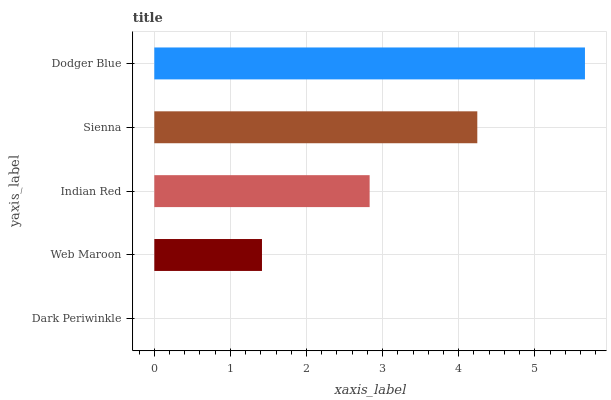Is Dark Periwinkle the minimum?
Answer yes or no. Yes. Is Dodger Blue the maximum?
Answer yes or no. Yes. Is Web Maroon the minimum?
Answer yes or no. No. Is Web Maroon the maximum?
Answer yes or no. No. Is Web Maroon greater than Dark Periwinkle?
Answer yes or no. Yes. Is Dark Periwinkle less than Web Maroon?
Answer yes or no. Yes. Is Dark Periwinkle greater than Web Maroon?
Answer yes or no. No. Is Web Maroon less than Dark Periwinkle?
Answer yes or no. No. Is Indian Red the high median?
Answer yes or no. Yes. Is Indian Red the low median?
Answer yes or no. Yes. Is Sienna the high median?
Answer yes or no. No. Is Dodger Blue the low median?
Answer yes or no. No. 